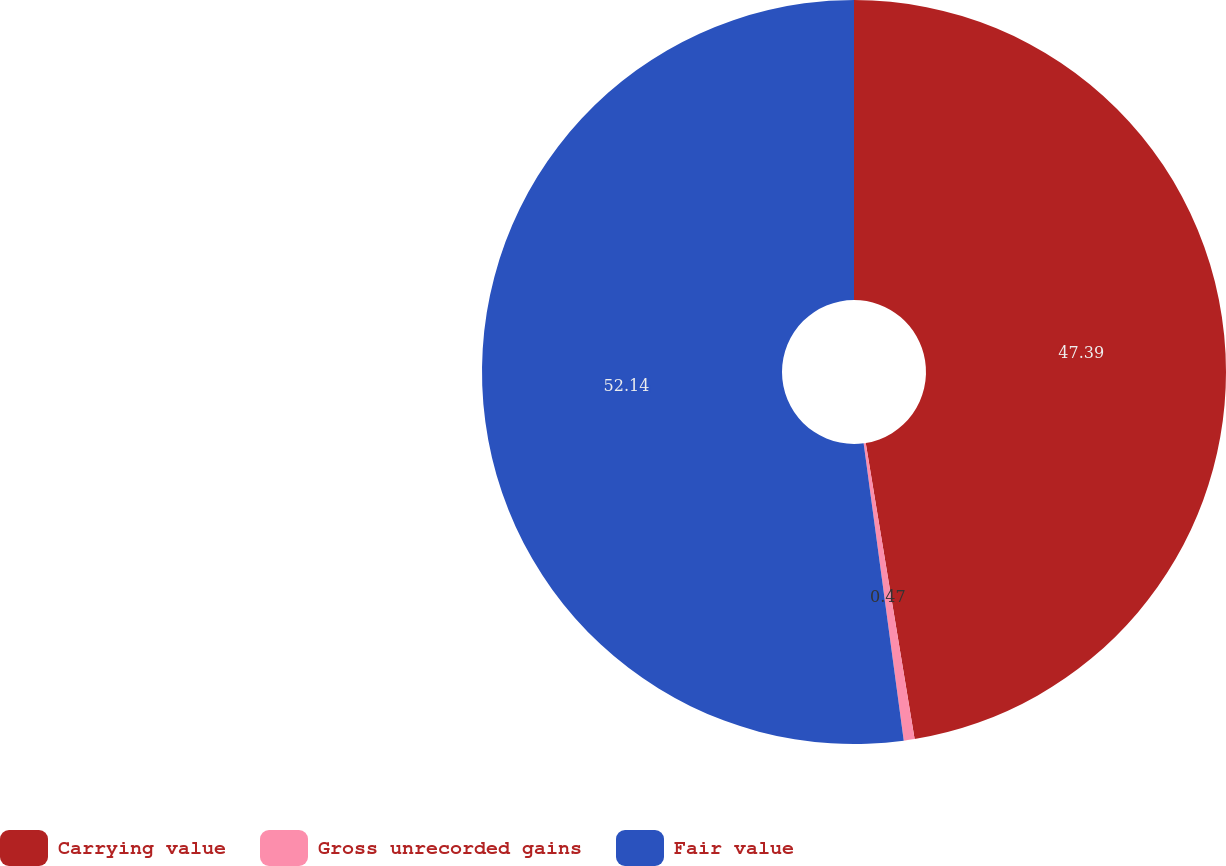Convert chart. <chart><loc_0><loc_0><loc_500><loc_500><pie_chart><fcel>Carrying value<fcel>Gross unrecorded gains<fcel>Fair value<nl><fcel>47.39%<fcel>0.47%<fcel>52.13%<nl></chart> 